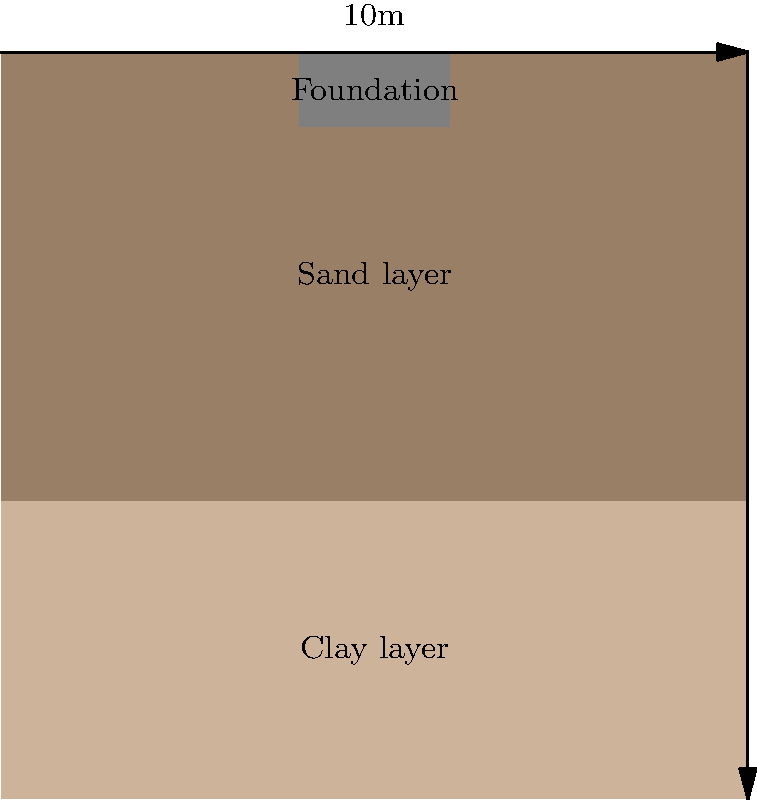A fast-fashion retailer is planning to build a new store on a two-layer soil profile. The top 4m is clay with a compression index ($C_c$) of 0.2 and an initial void ratio ($e_0$) of 0.9. The bottom 6m is sand. The foundation is 2m wide and applies a uniform pressure of 250 kPa. The average effective vertical stress in the clay layer before loading is 40 kPa. Estimate the settlement of the foundation due to consolidation of the clay layer. To estimate the settlement of the foundation, we'll use the consolidation settlement equation:

$$ S = \frac{C_c H}{1 + e_0} \log_{10}\left(\frac{\sigma'_0 + \Delta\sigma}{\sigma'_0}\right) $$

Where:
$S$ = Settlement
$C_c$ = Compression index = 0.2
$H$ = Thickness of the clay layer = 4m
$e_0$ = Initial void ratio = 0.9
$\sigma'_0$ = Initial effective stress = 40 kPa
$\Delta\sigma$ = Change in stress due to foundation load

Steps:
1. Calculate $\Delta\sigma$ at the middle of the clay layer:
   $\Delta\sigma = 250 \text{ kPa} \times \frac{2}{2+2} = 125 \text{ kPa}$

2. Apply the consolidation settlement equation:
   $$ S = \frac{0.2 \times 4}{1 + 0.9} \log_{10}\left(\frac{40 + 125}{40}\right) $$

3. Simplify:
   $$ S = \frac{0.8}{1.9} \log_{10}\left(\frac{165}{40}\right) $$

4. Calculate:
   $$ S = 0.421 \times \log_{10}(4.125) = 0.421 \times 0.6155 = 0.259 \text{ m} $$

5. Convert to cm:
   $$ S = 0.259 \text{ m} \times 100 \text{ cm/m} = 25.9 \text{ cm} $$
Answer: 25.9 cm 